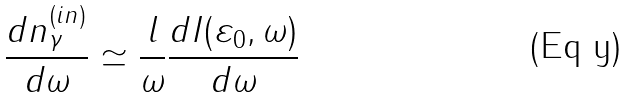<formula> <loc_0><loc_0><loc_500><loc_500>\frac { d n _ { \gamma } ^ { ( i n ) } } { d \omega } \simeq \frac { l } { \omega } \frac { d I ( \varepsilon _ { 0 } , \omega ) } { d \omega }</formula> 